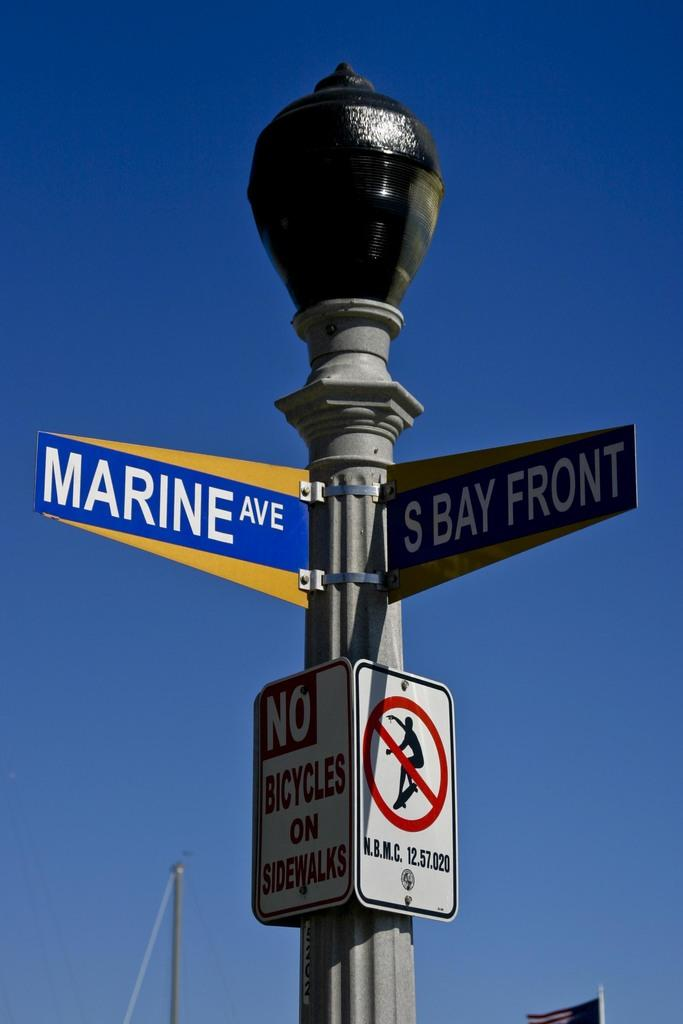<image>
Present a compact description of the photo's key features. A sign post reads Marine Ave and S Bay Front. 